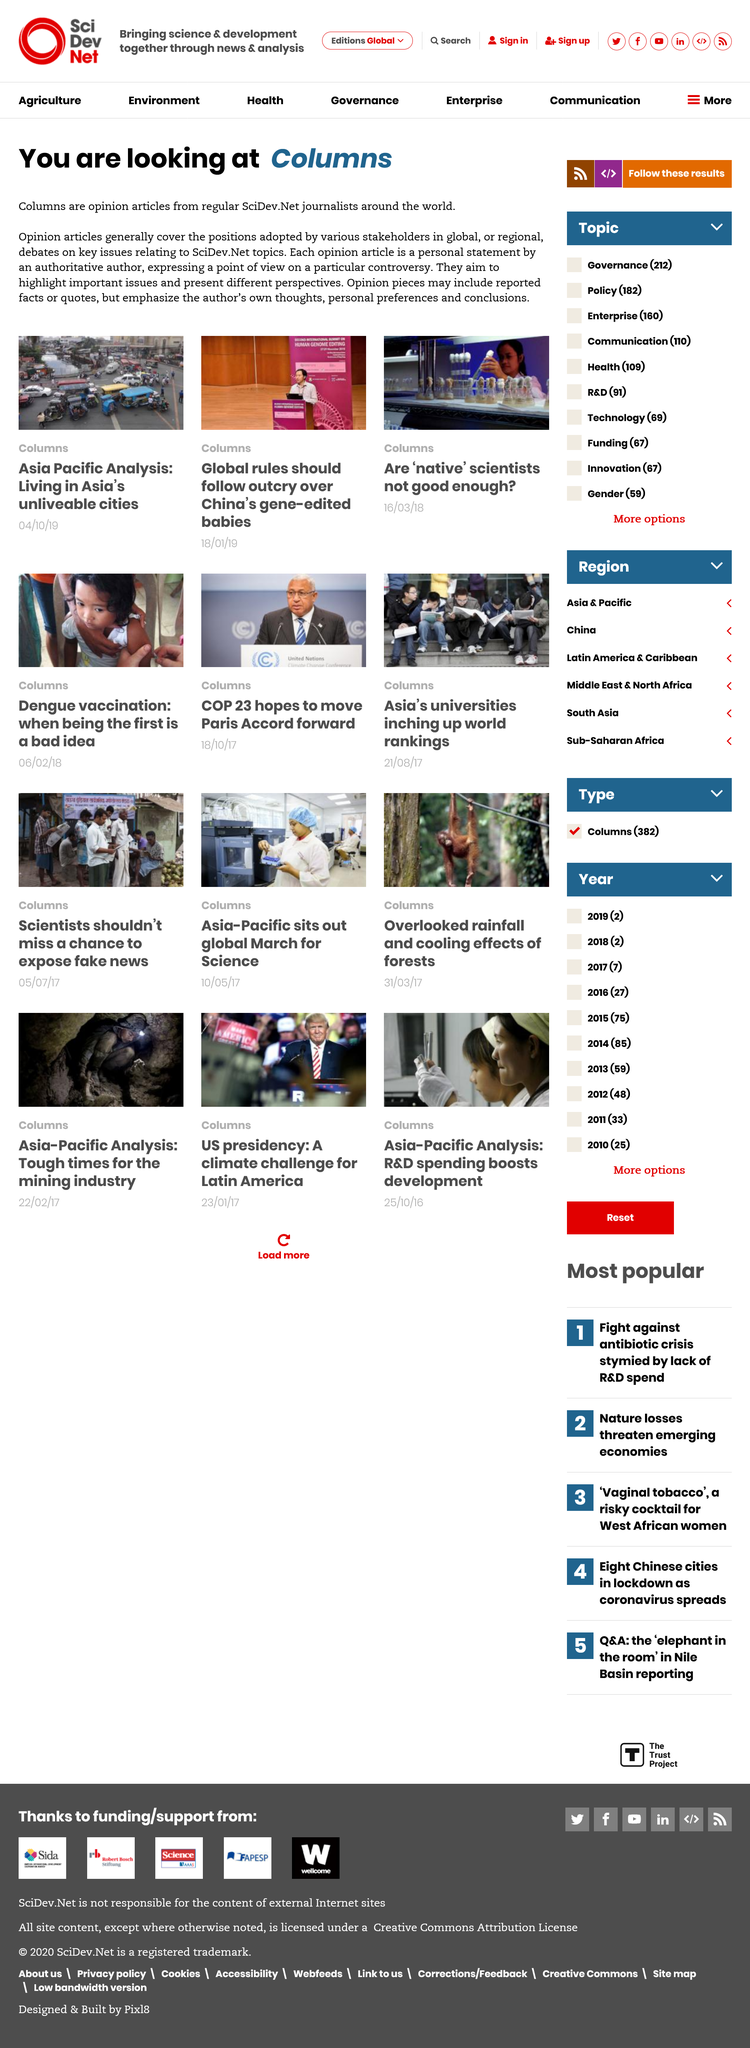Give some essential details in this illustration. It is the responsibility of journalists at SciDev.net, located in various parts of the world, to write Columns articles. The title of this article is "You are looking at Columns". It is possible for articles to include both facts and opinions. 